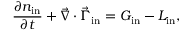Convert formula to latex. <formula><loc_0><loc_0><loc_500><loc_500>\frac { \partial { n _ { i n } } } { \partial { t } } + \vec { \nabla } \cdot \vec { \Gamma } _ { i n } = G _ { i n } - L _ { i n } ,</formula> 